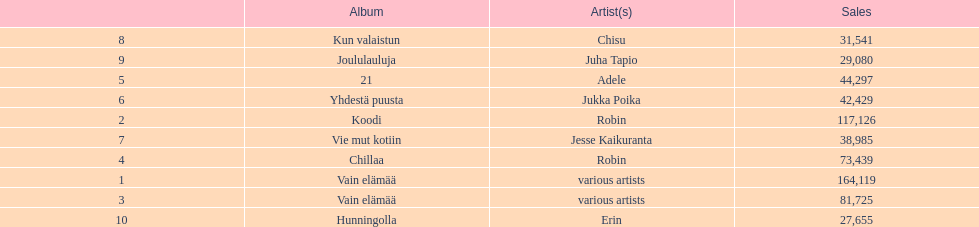What album is listed before 21? Chillaa. 